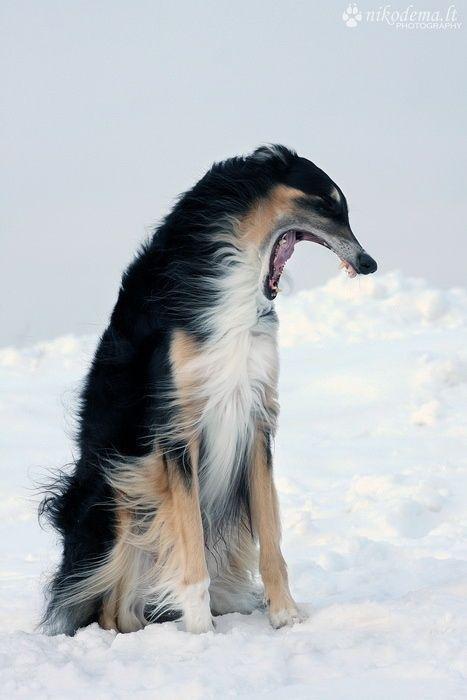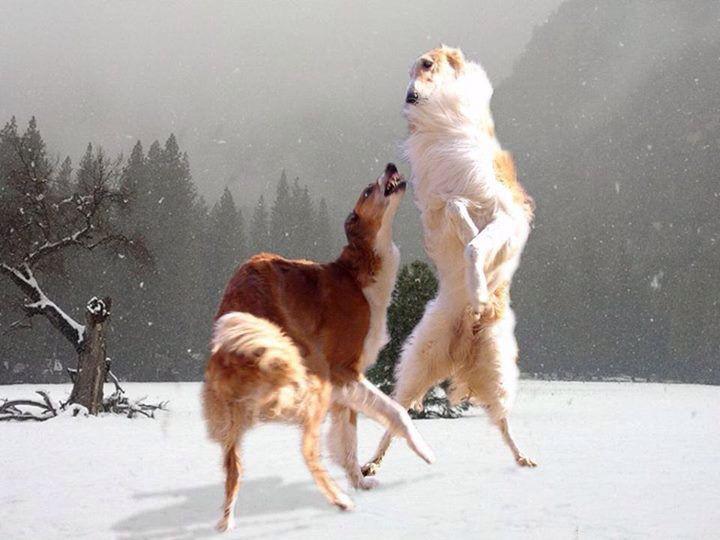The first image is the image on the left, the second image is the image on the right. Assess this claim about the two images: "Each image contains a single hound dog, and one image shows a dog in a reclining position with both front paws extended forward.". Correct or not? Answer yes or no. No. The first image is the image on the left, the second image is the image on the right. For the images shown, is this caption "The dog in the image on the right is lying down." true? Answer yes or no. No. 